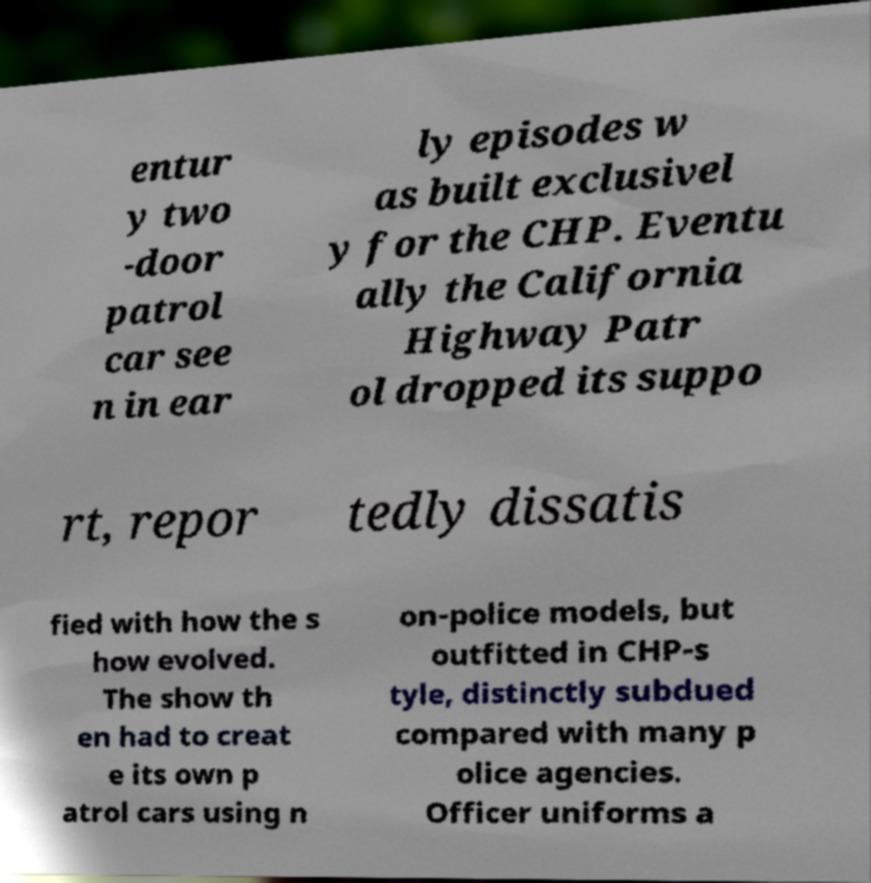Can you accurately transcribe the text from the provided image for me? entur y two -door patrol car see n in ear ly episodes w as built exclusivel y for the CHP. Eventu ally the California Highway Patr ol dropped its suppo rt, repor tedly dissatis fied with how the s how evolved. The show th en had to creat e its own p atrol cars using n on-police models, but outfitted in CHP-s tyle, distinctly subdued compared with many p olice agencies. Officer uniforms a 